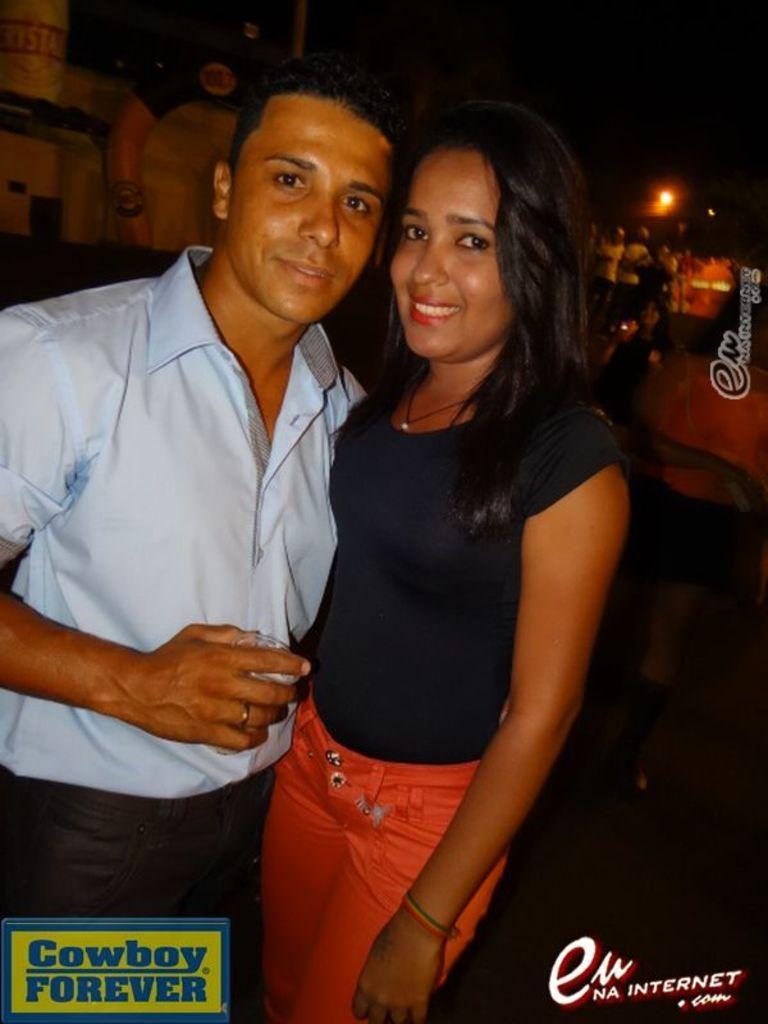Please provide a concise description of this image. In the center of the image we can see man and woman standing on the ground. In the background we can see light, persons and building. 